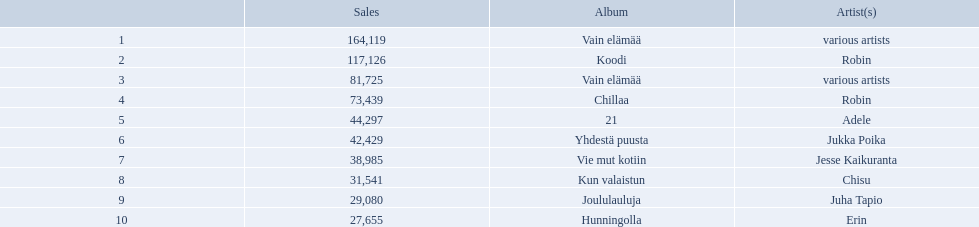Which artists' albums reached number one in finland during 2012? 164,119, 117,126, 81,725, 73,439, 44,297, 42,429, 38,985, 31,541, 29,080, 27,655. What were the sales figures of these albums? Various artists, robin, various artists, robin, adele, jukka poika, jesse kaikuranta, chisu, juha tapio, erin. And did adele or chisu have more sales during this period? Adele. 